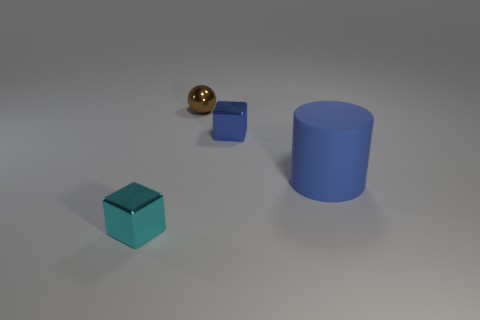Add 2 big red metallic spheres. How many objects exist? 6 Subtract all cylinders. How many objects are left? 3 Add 1 large matte cubes. How many large matte cubes exist? 1 Subtract 1 blue cylinders. How many objects are left? 3 Subtract all rubber objects. Subtract all tiny gray blocks. How many objects are left? 3 Add 4 cyan shiny things. How many cyan shiny things are left? 5 